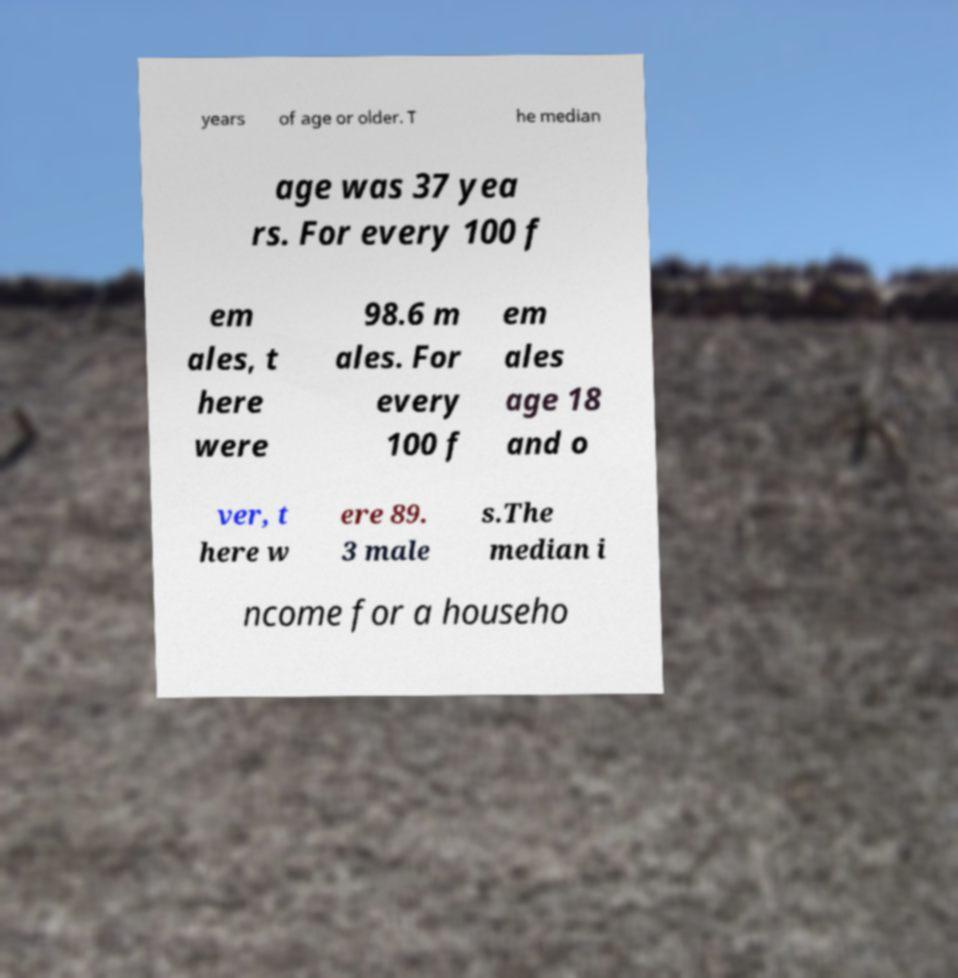Can you accurately transcribe the text from the provided image for me? years of age or older. T he median age was 37 yea rs. For every 100 f em ales, t here were 98.6 m ales. For every 100 f em ales age 18 and o ver, t here w ere 89. 3 male s.The median i ncome for a househo 